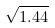<formula> <loc_0><loc_0><loc_500><loc_500>\sqrt { 1 . 4 4 }</formula> 